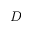<formula> <loc_0><loc_0><loc_500><loc_500>D</formula> 